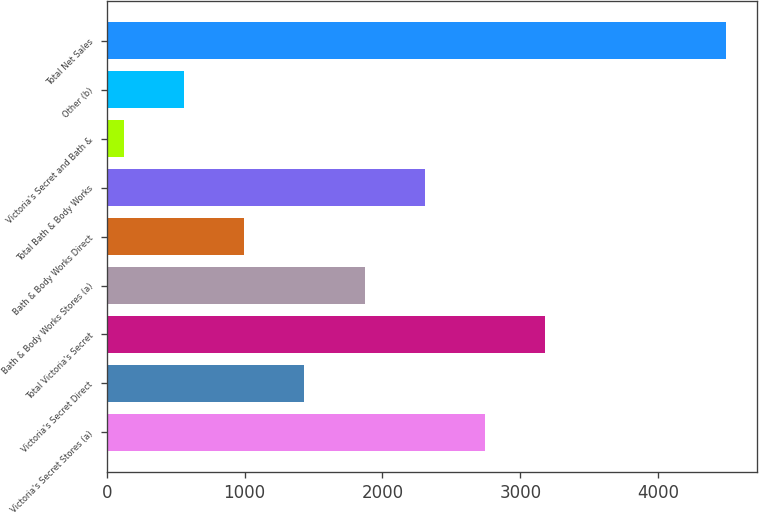<chart> <loc_0><loc_0><loc_500><loc_500><bar_chart><fcel>Victoria's Secret Stores (a)<fcel>Victoria's Secret Direct<fcel>Total Victoria's Secret<fcel>Bath & Body Works Stores (a)<fcel>Bath & Body Works Direct<fcel>Total Bath & Body Works<fcel>Victoria's Secret and Bath &<fcel>Other (b)<fcel>Total Net Sales<nl><fcel>2743<fcel>1433.5<fcel>3179.5<fcel>1870<fcel>997<fcel>2306.5<fcel>124<fcel>560.5<fcel>4489<nl></chart> 